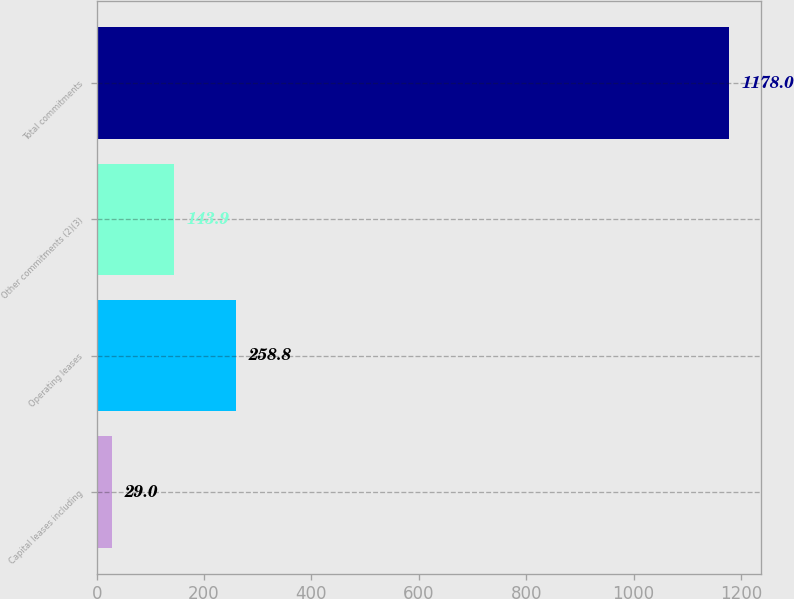Convert chart. <chart><loc_0><loc_0><loc_500><loc_500><bar_chart><fcel>Capital leases including<fcel>Operating leases<fcel>Other commitments (2)(3)<fcel>Total commitments<nl><fcel>29<fcel>258.8<fcel>143.9<fcel>1178<nl></chart> 